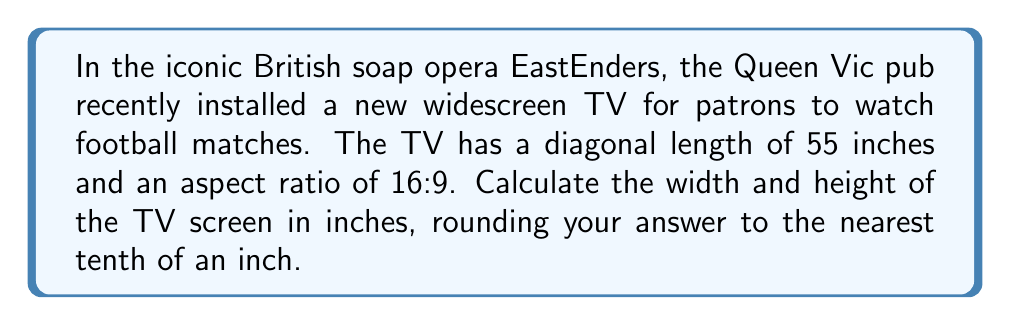Give your solution to this math problem. Let's approach this step-by-step:

1) Let the width be $w$ and the height be $h$.

2) The aspect ratio of 16:9 means that $\frac{w}{h} = \frac{16}{9}$, or $w = \frac{16}{9}h$.

3) We know that the diagonal $d$ is 55 inches. Using the Pythagorean theorem:

   $$d^2 = w^2 + h^2$$

4) Substituting $w = \frac{16}{9}h$ into this equation:

   $$55^2 = (\frac{16}{9}h)^2 + h^2$$

5) Simplify:

   $$3025 = \frac{256}{81}h^2 + h^2 = \frac{337}{81}h^2$$

6) Solve for $h$:

   $$h^2 = \frac{3025 * 81}{337} = 725.6675$$
   $$h = \sqrt{725.6675} \approx 26.9 \text{ inches}$$

7) Now we can find $w$:

   $$w = \frac{16}{9}h \approx \frac{16}{9} * 26.9 \approx 47.8 \text{ inches}$$

8) Rounding to the nearest tenth:
   Height ≈ 26.9 inches
   Width ≈ 47.8 inches
Answer: Width: 47.8 inches, Height: 26.9 inches 